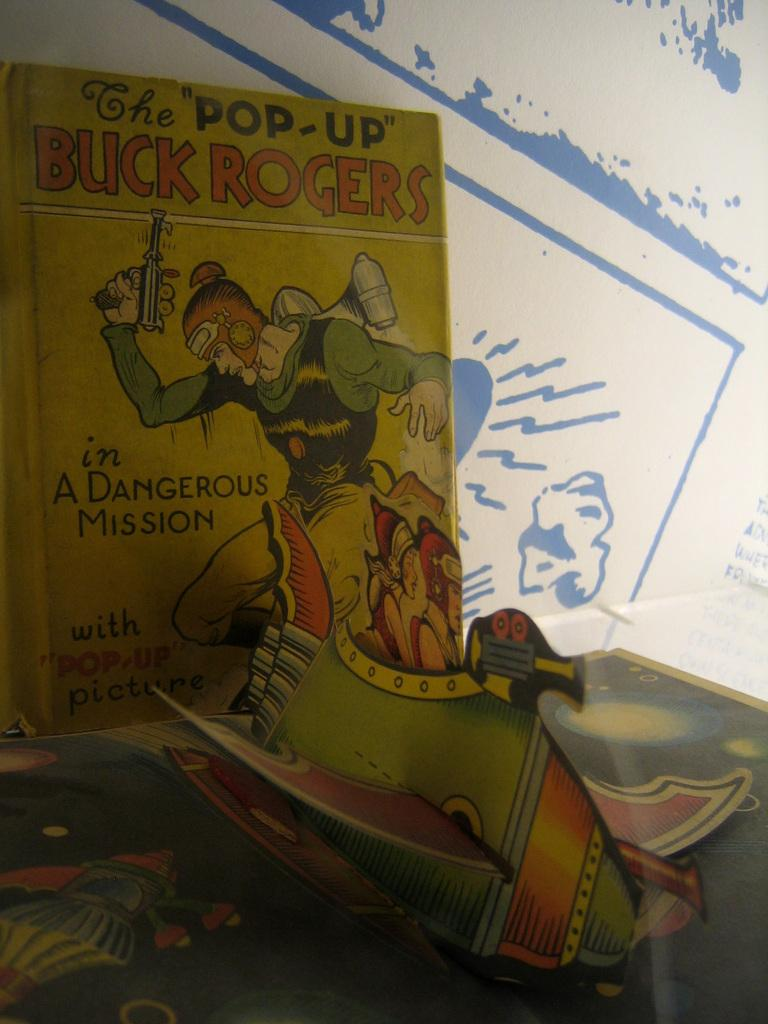<image>
Render a clear and concise summary of the photo. A book is open called The Buck Rogers pop-up book. 